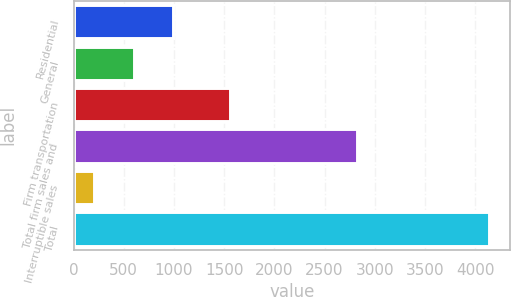<chart> <loc_0><loc_0><loc_500><loc_500><bar_chart><fcel>Residential<fcel>General<fcel>Firm transportation<fcel>Total firm sales and<fcel>Interruptible sales<fcel>Total<nl><fcel>994.2<fcel>601.1<fcel>1557<fcel>2826<fcel>208<fcel>4139<nl></chart> 